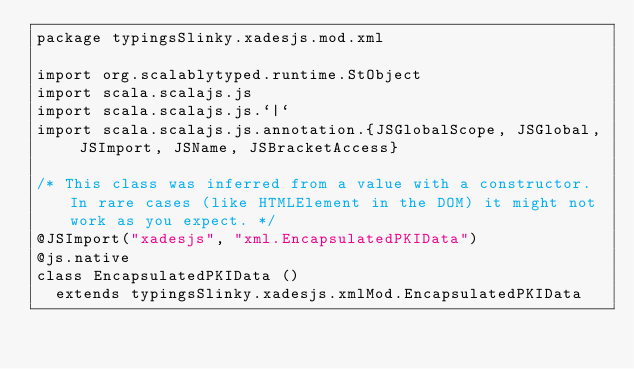<code> <loc_0><loc_0><loc_500><loc_500><_Scala_>package typingsSlinky.xadesjs.mod.xml

import org.scalablytyped.runtime.StObject
import scala.scalajs.js
import scala.scalajs.js.`|`
import scala.scalajs.js.annotation.{JSGlobalScope, JSGlobal, JSImport, JSName, JSBracketAccess}

/* This class was inferred from a value with a constructor. In rare cases (like HTMLElement in the DOM) it might not work as you expect. */
@JSImport("xadesjs", "xml.EncapsulatedPKIData")
@js.native
class EncapsulatedPKIData ()
  extends typingsSlinky.xadesjs.xmlMod.EncapsulatedPKIData
</code> 